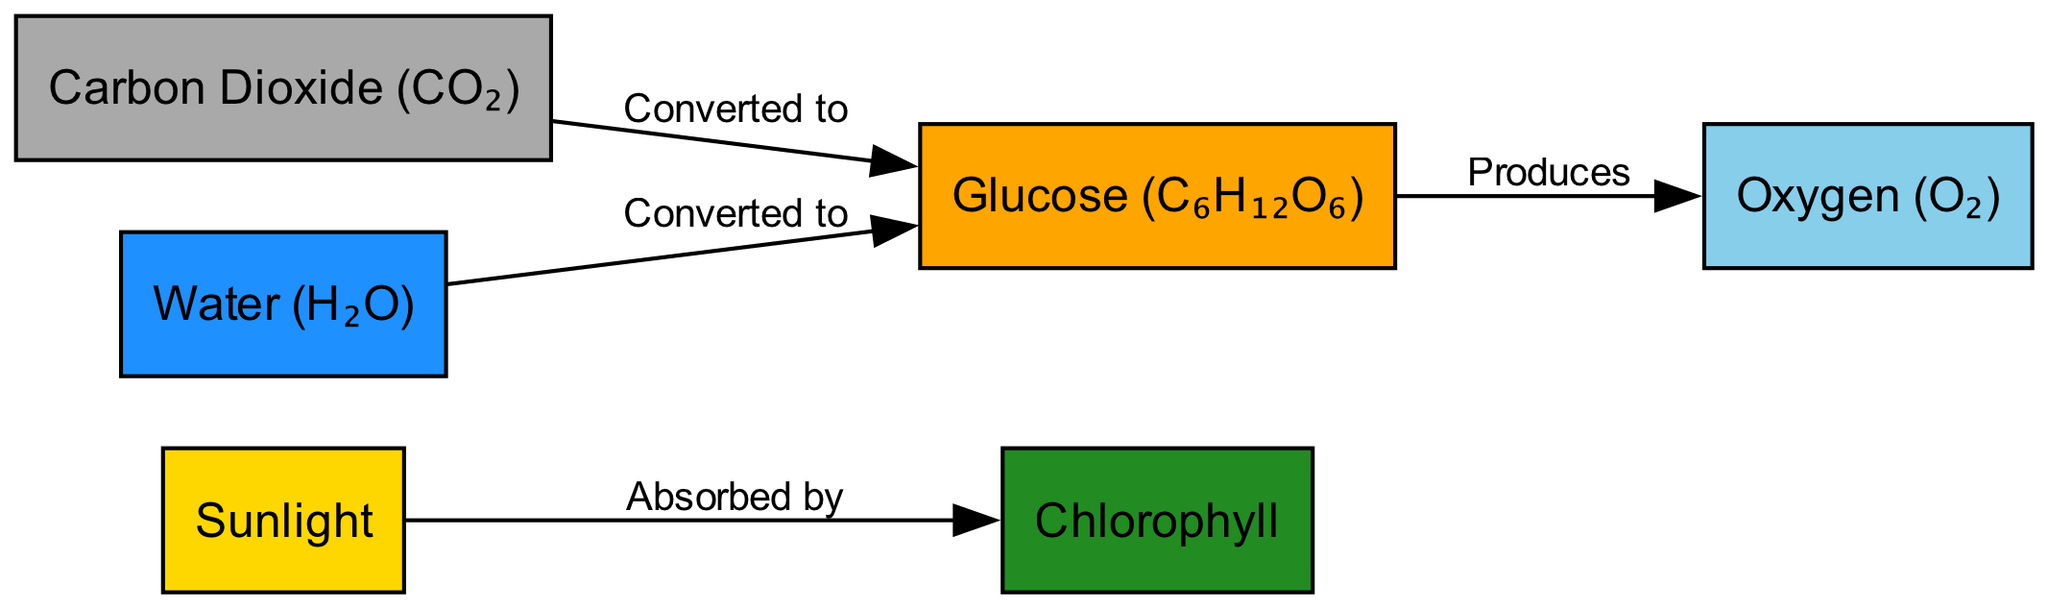What are the primary nodes involved in photosynthesis as depicted in the diagram? The diagram lists six primary nodes: Sunlight, Chlorophyll, Carbon Dioxide (CO₂), Water (H₂O), Glucose (C₆H₁₂O₆), and Oxygen (O₂).
Answer: Sunlight, Chlorophyll, Carbon Dioxide, Water, Glucose, Oxygen What is produced from glucose in the process of photosynthesis? The diagram indicates that glucose produces oxygen, showing the direct relationship between these two nodes.
Answer: Oxygen How many nodes are present in this diagram? Counting the nodes listed in the diagram, there are six distinct nodes describing different components involved in photosynthesis.
Answer: 6 What is sunlight absorbed by? According to the edges in the diagram, sunlight is absorbed by chlorophyll, which is a key step in the photosynthesis process.
Answer: Chlorophyll What do carbon dioxide and water convert to? The diagram shows that both carbon dioxide and water are converted to glucose, indicating their role in the photosynthesis process.
Answer: Glucose How many edges connect the nodes in the diagram? The diagram has a total of four edges, representing the relationships between the various nodes involved in photosynthesis.
Answer: 4 What linking relationship exists between water and glucose? The diagram illustrates that water is converted to glucose, establishing a direct conversion relationship between these two elements within the photosynthesis process.
Answer: Converted to Which process is essential for oxygen production as shown in the diagram? The diagram highlights that glucose, which is produced from carbon dioxide and water, produces oxygen as a result, emphasizing the essential role of photosynthesis in creating oxygen.
Answer: Photosynthesis 